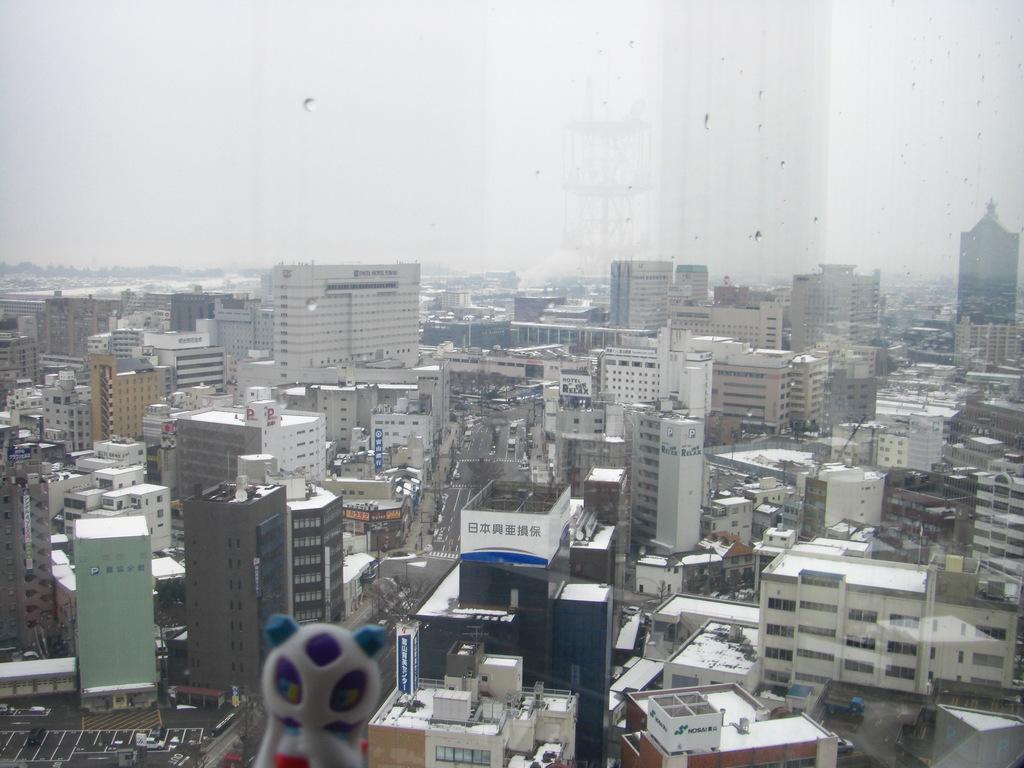Could you give a brief overview of what you see in this image? There are many buildings and there is a road at the center. 